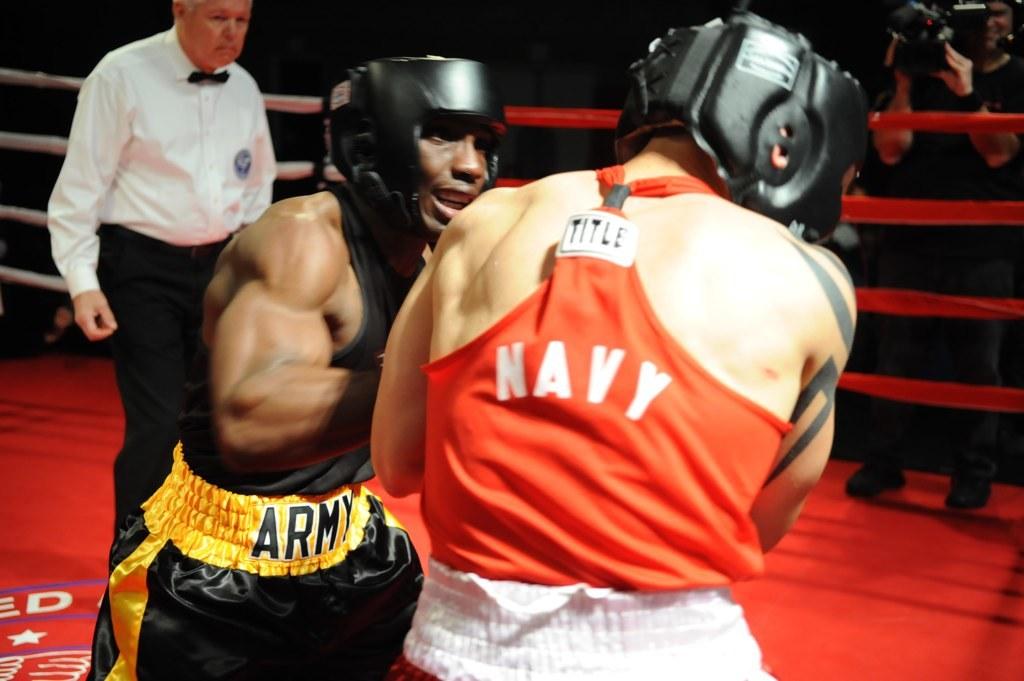Navy vs  who?
Offer a very short reply. Army. What is the brand of clothing the person in red is wearing?
Your answer should be compact. Title. 